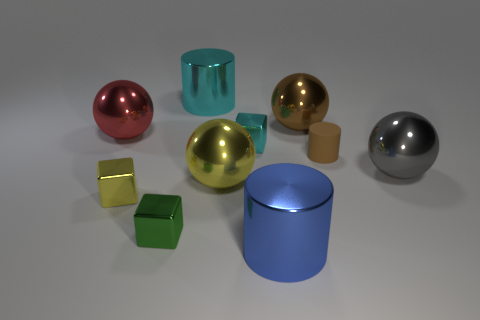There is a large metallic thing that is the same color as the rubber thing; what is its shape?
Provide a succinct answer. Sphere. Do the large cylinder that is in front of the big gray metallic ball and the tiny matte cylinder have the same color?
Make the answer very short. No. The tiny yellow object that is the same material as the small cyan object is what shape?
Provide a short and direct response. Cube. The metal sphere that is both to the left of the small cyan metal thing and behind the rubber cylinder is what color?
Ensure brevity in your answer.  Red. How big is the cyan shiny thing that is behind the tiny object that is behind the small matte object?
Make the answer very short. Large. Are there any other small cylinders that have the same color as the small cylinder?
Give a very brief answer. No. Are there the same number of big brown things that are behind the big cyan cylinder and cubes?
Your response must be concise. No. How many yellow metal things are there?
Your answer should be compact. 2. What is the shape of the thing that is behind the gray ball and on the left side of the green metallic thing?
Your response must be concise. Sphere. There is a cube that is behind the tiny rubber cylinder; is it the same color as the large object right of the tiny matte thing?
Give a very brief answer. No. 